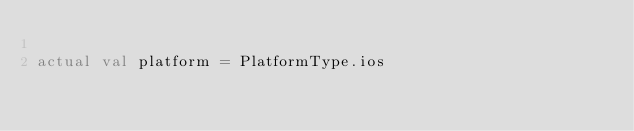<code> <loc_0><loc_0><loc_500><loc_500><_Kotlin_>
actual val platform = PlatformType.ios
</code> 